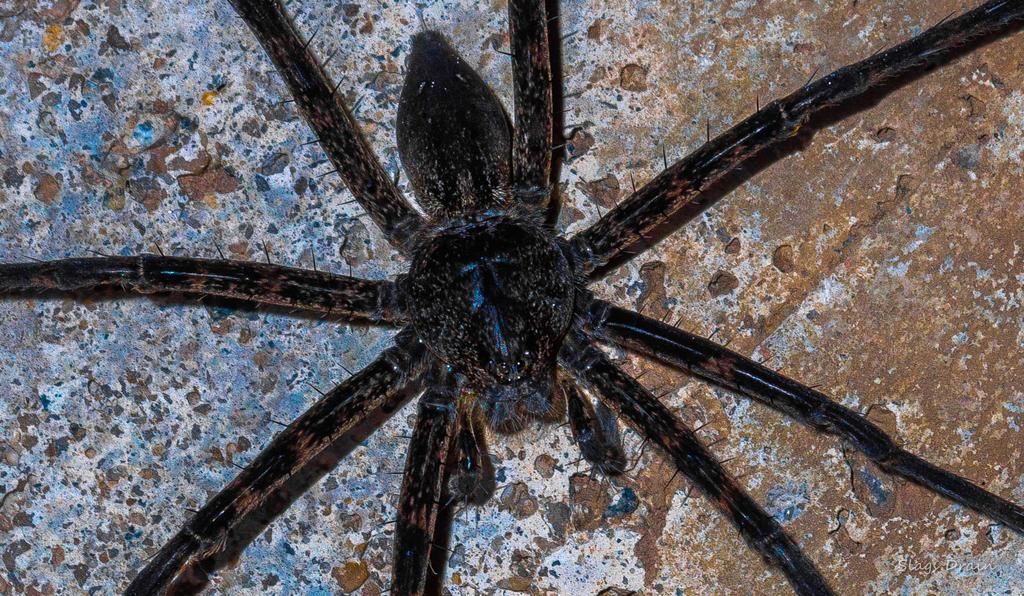What is the main subject in the center of the image? There is a spider in the center of the image. How many clovers are surrounding the spider in the image? There are no clovers present in the image; it only features a spider in the center. 